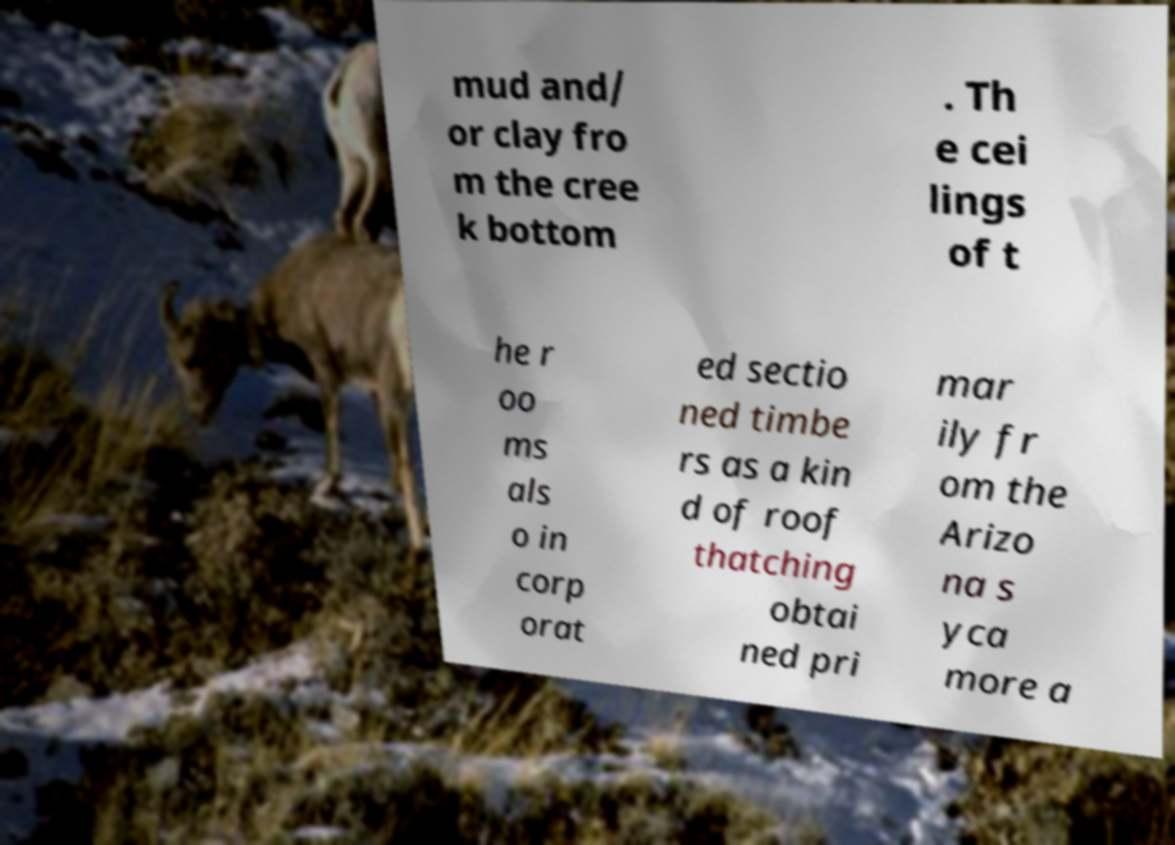Can you read and provide the text displayed in the image?This photo seems to have some interesting text. Can you extract and type it out for me? mud and/ or clay fro m the cree k bottom . Th e cei lings of t he r oo ms als o in corp orat ed sectio ned timbe rs as a kin d of roof thatching obtai ned pri mar ily fr om the Arizo na s yca more a 